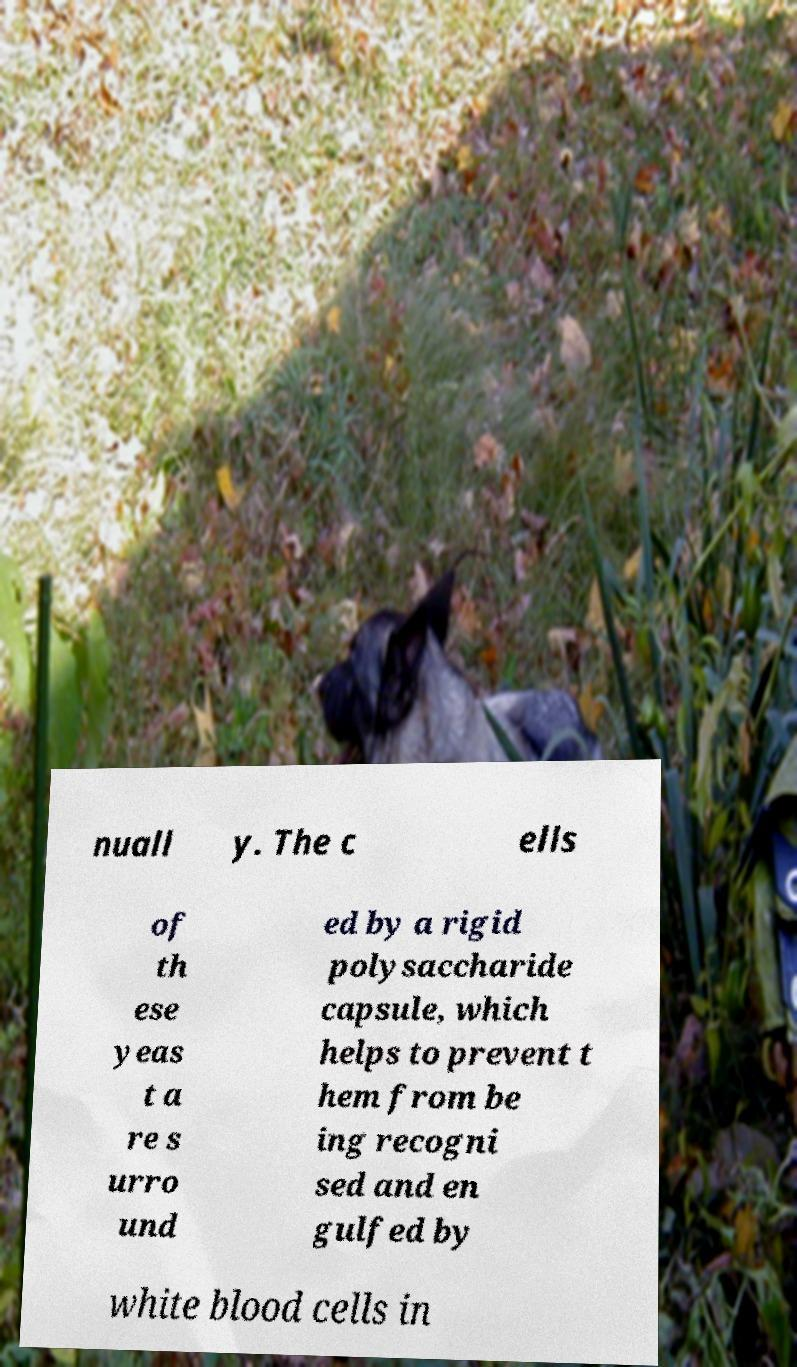Could you assist in decoding the text presented in this image and type it out clearly? nuall y. The c ells of th ese yeas t a re s urro und ed by a rigid polysaccharide capsule, which helps to prevent t hem from be ing recogni sed and en gulfed by white blood cells in 